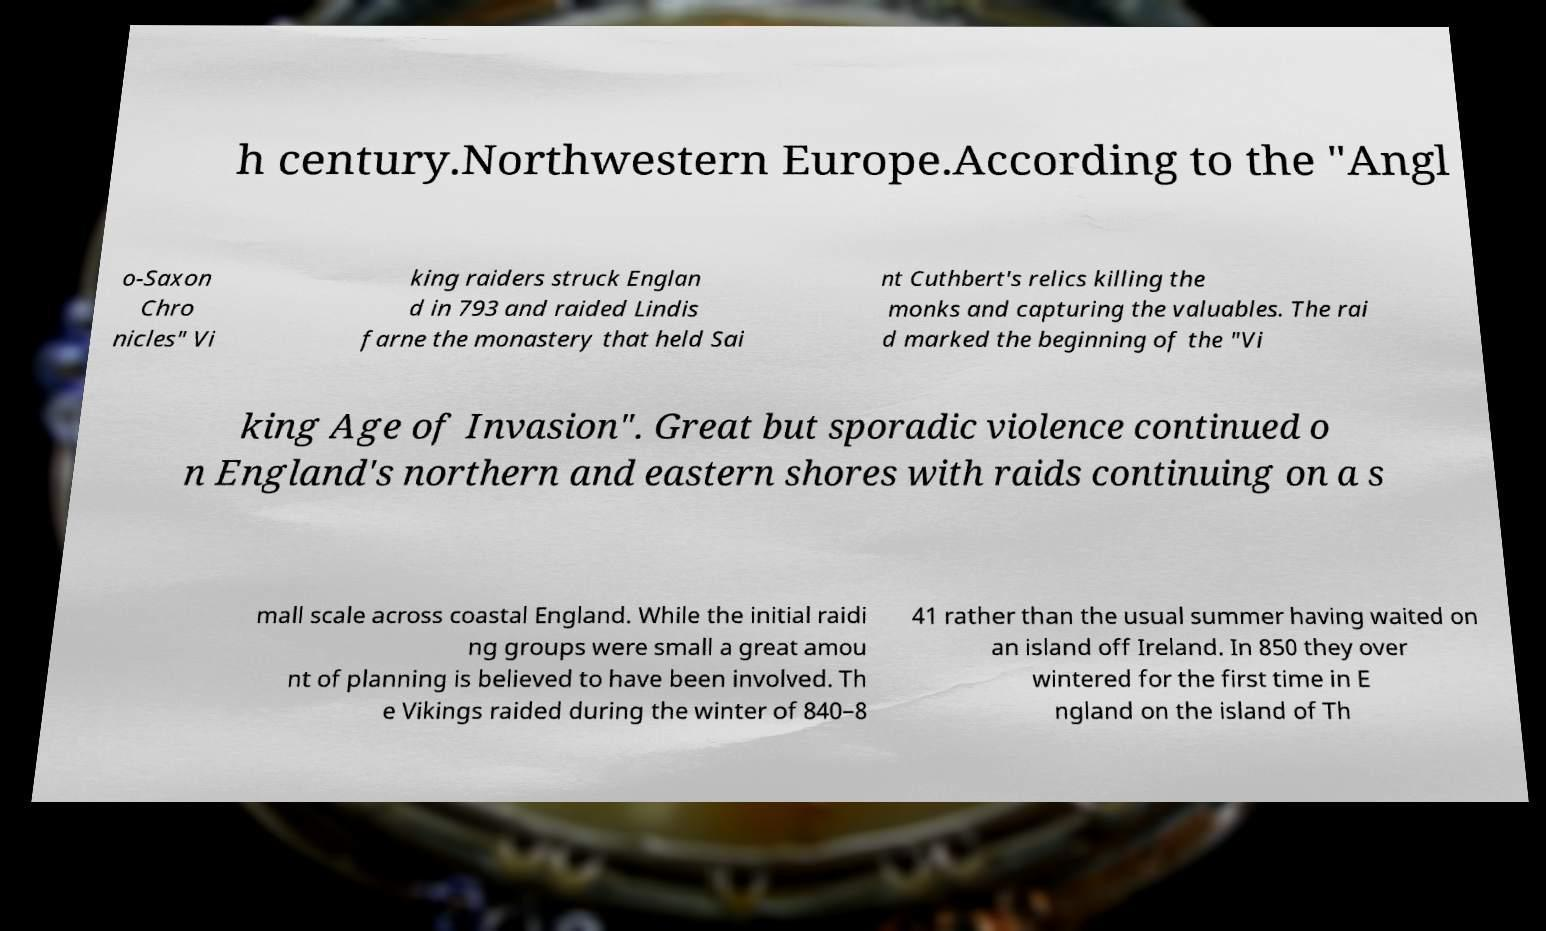For documentation purposes, I need the text within this image transcribed. Could you provide that? h century.Northwestern Europe.According to the "Angl o-Saxon Chro nicles" Vi king raiders struck Englan d in 793 and raided Lindis farne the monastery that held Sai nt Cuthbert's relics killing the monks and capturing the valuables. The rai d marked the beginning of the "Vi king Age of Invasion". Great but sporadic violence continued o n England's northern and eastern shores with raids continuing on a s mall scale across coastal England. While the initial raidi ng groups were small a great amou nt of planning is believed to have been involved. Th e Vikings raided during the winter of 840–8 41 rather than the usual summer having waited on an island off Ireland. In 850 they over wintered for the first time in E ngland on the island of Th 